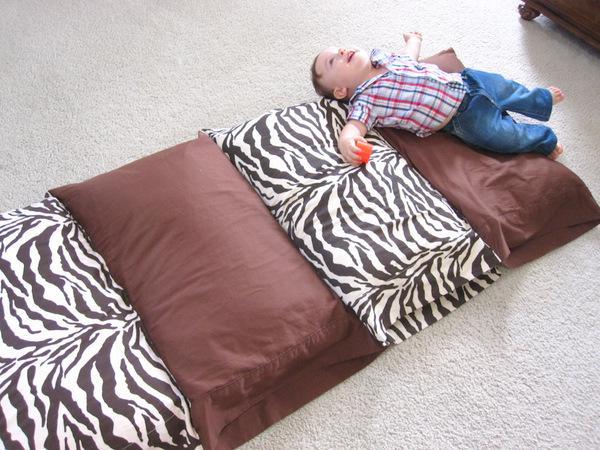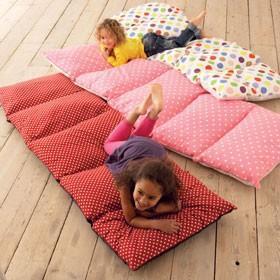The first image is the image on the left, the second image is the image on the right. Evaluate the accuracy of this statement regarding the images: "The are at most 3 children present". Is it true? Answer yes or no. Yes. The first image is the image on the left, the second image is the image on the right. Examine the images to the left and right. Is the description "There is a child on top of the pillow in at least one of the images." accurate? Answer yes or no. Yes. 